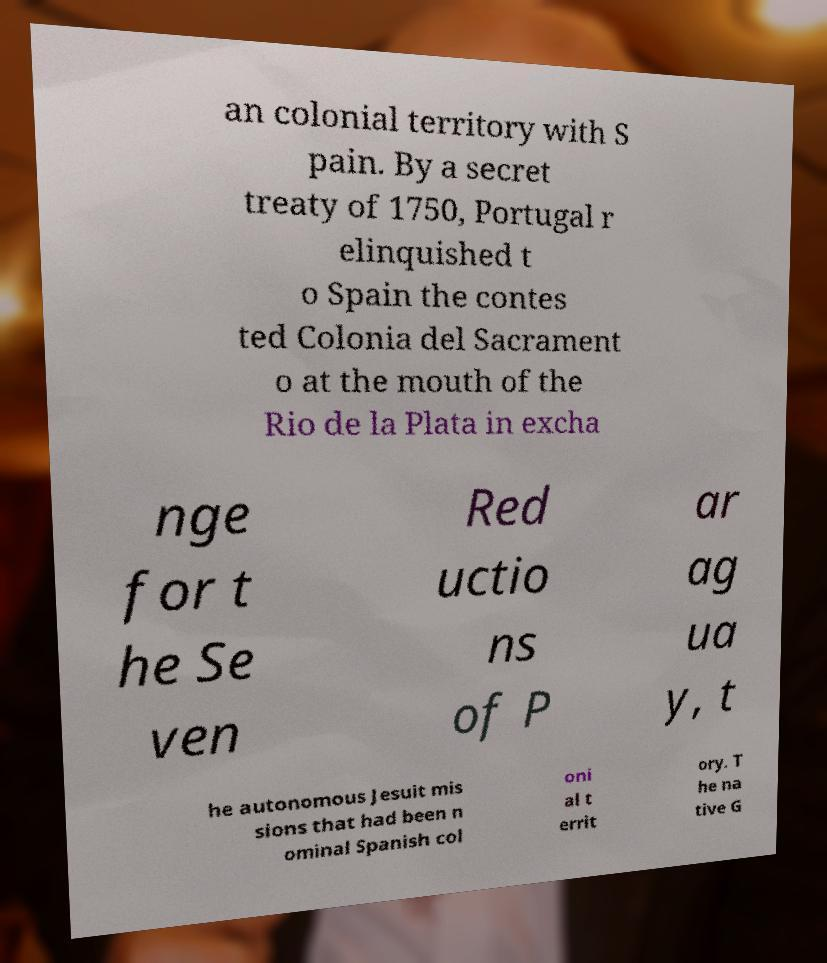What messages or text are displayed in this image? I need them in a readable, typed format. an colonial territory with S pain. By a secret treaty of 1750, Portugal r elinquished t o Spain the contes ted Colonia del Sacrament o at the mouth of the Rio de la Plata in excha nge for t he Se ven Red uctio ns of P ar ag ua y, t he autonomous Jesuit mis sions that had been n ominal Spanish col oni al t errit ory. T he na tive G 